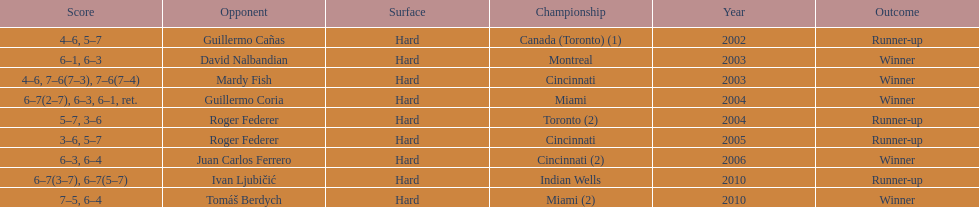What is the number of times roger federer finished as a runner-up? 2. 